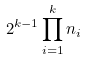Convert formula to latex. <formula><loc_0><loc_0><loc_500><loc_500>2 ^ { k - 1 } \prod _ { i = 1 } ^ { k } n _ { i }</formula> 